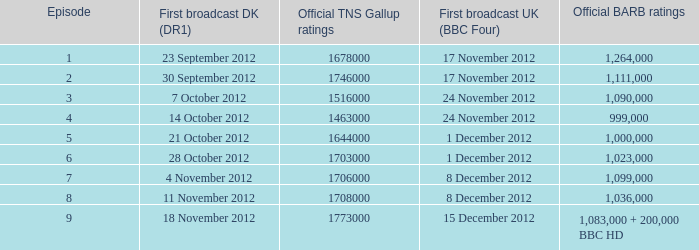When was the episode with a 1,036,000 BARB rating first aired in Denmark? 11 November 2012. 